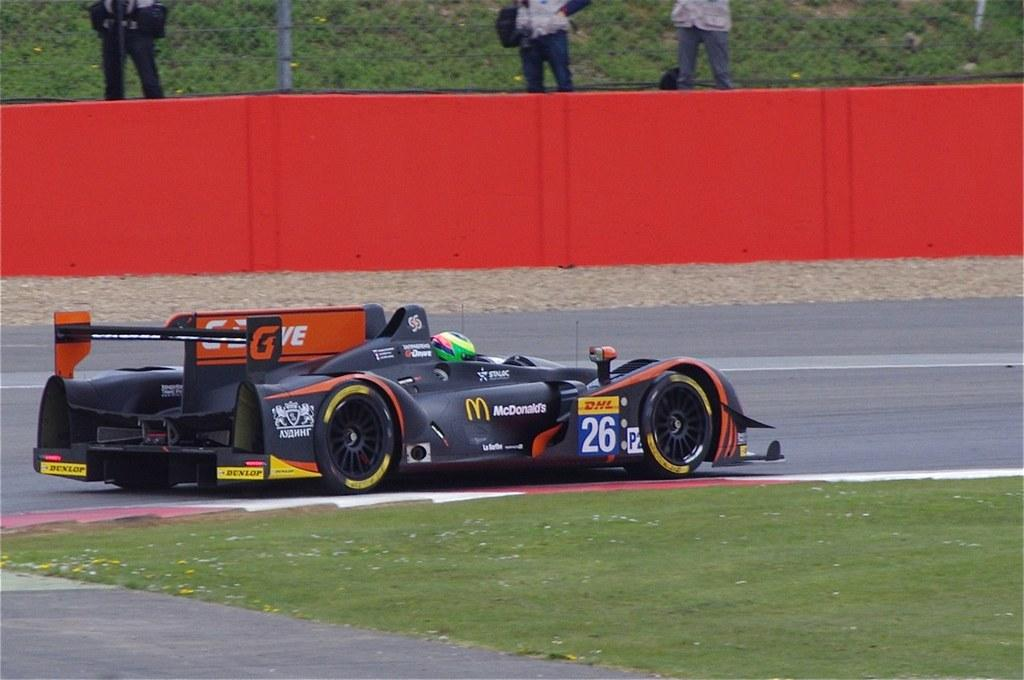What is the main subject of the image? The main subject of the image is a racing car. Where is the racing car located? The racing car is on the road in the image. Can you describe the people in the image? The people in the image are standing and wearing clothes. What type of surface is visible in the image? There is a road and grass visible in the image. What design elements can be seen in the image? There are red borders and a fence in the image. What type of scarf is the racing car wearing in the image? The racing car is not wearing a scarf in the image, as it is an inanimate object and does not wear clothing. How does the beginner racer perform in the image? There is no mention of a beginner racer in the image, so we cannot comment on their performance. 